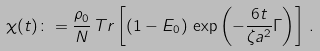<formula> <loc_0><loc_0><loc_500><loc_500>\chi ( t ) \colon = \frac { \rho _ { 0 } } { N } \, { T r } \left [ ( 1 - E _ { 0 } ) \, \exp \left ( - \frac { 6 t } { \zeta a ^ { 2 } } \Gamma \right ) \right ] \, .</formula> 